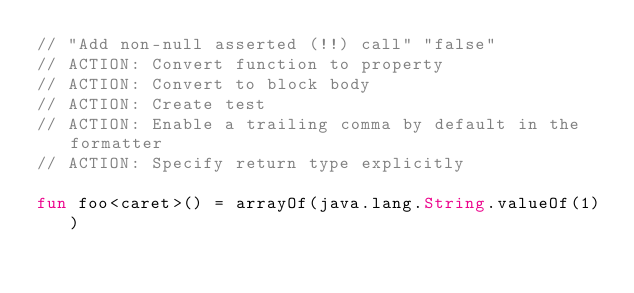<code> <loc_0><loc_0><loc_500><loc_500><_Kotlin_>// "Add non-null asserted (!!) call" "false"
// ACTION: Convert function to property
// ACTION: Convert to block body
// ACTION: Create test
// ACTION: Enable a trailing comma by default in the formatter
// ACTION: Specify return type explicitly

fun foo<caret>() = arrayOf(java.lang.String.valueOf(1))</code> 